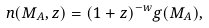<formula> <loc_0><loc_0><loc_500><loc_500>n ( M _ { A } , z ) = ( 1 + z ) ^ { - w } g ( M _ { A } ) ,</formula> 